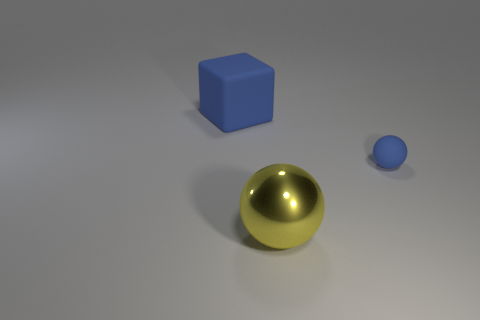Can you describe the lighting and shadows in the scene? The scene is lit by what appears to be a single light source above and to the right, casting soft-edged shadows to the lower left of the objects. The direction and softness of the shadows indicate a diffused light source, creating a calm and simplistic atmosphere in the composition. 